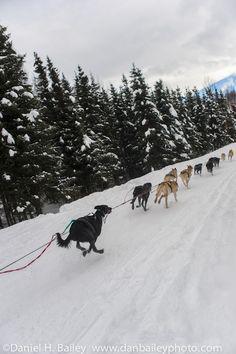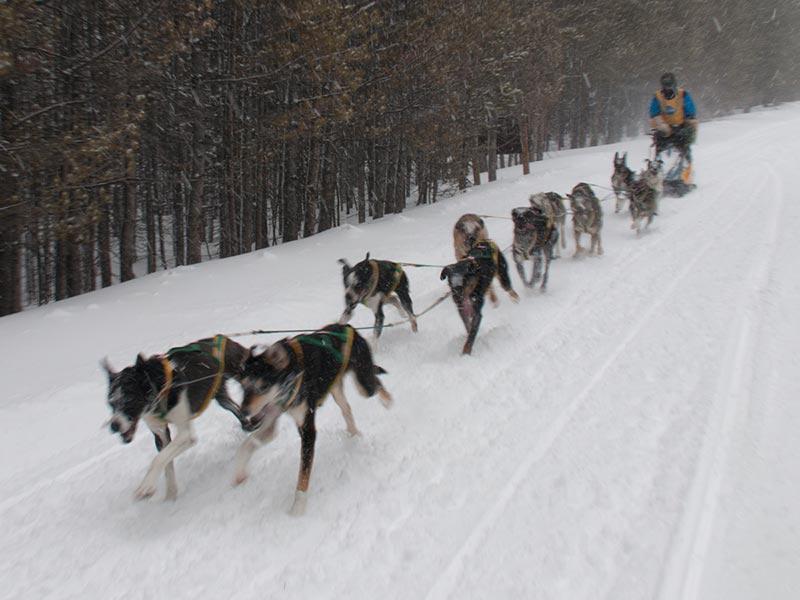The first image is the image on the left, the second image is the image on the right. Considering the images on both sides, is "In at least one photo, the dogs are running." valid? Answer yes or no. Yes. The first image is the image on the left, the second image is the image on the right. Given the left and right images, does the statement "There are no more than 2 people present, dog sledding." hold true? Answer yes or no. Yes. 